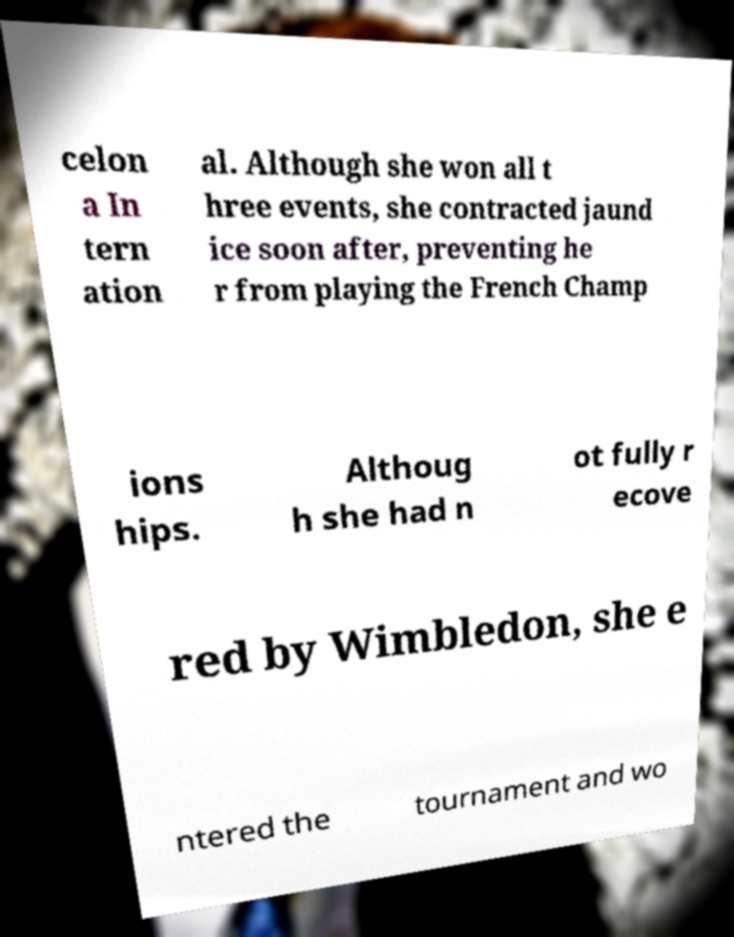Can you accurately transcribe the text from the provided image for me? celon a In tern ation al. Although she won all t hree events, she contracted jaund ice soon after, preventing he r from playing the French Champ ions hips. Althoug h she had n ot fully r ecove red by Wimbledon, she e ntered the tournament and wo 